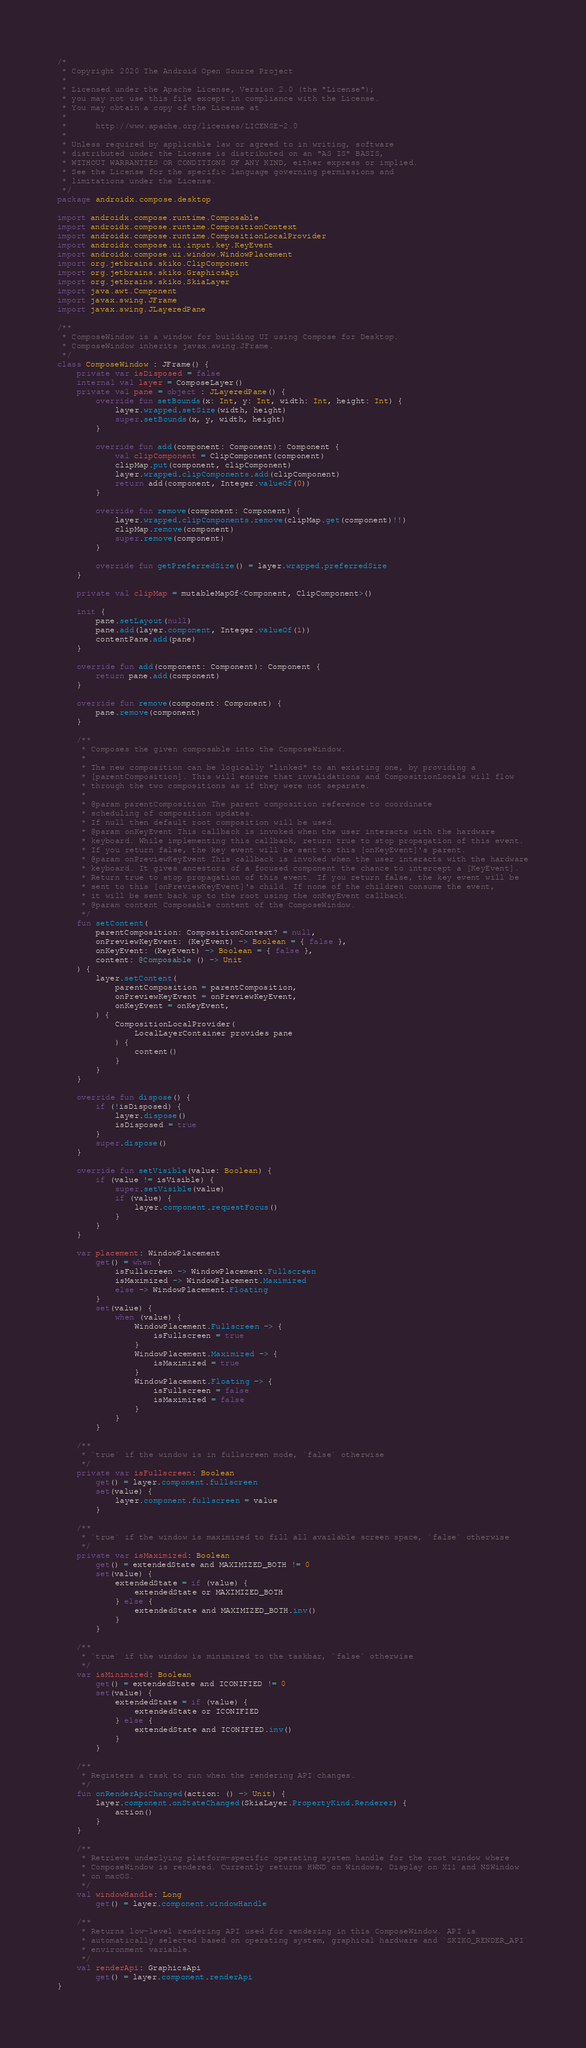<code> <loc_0><loc_0><loc_500><loc_500><_Kotlin_>/*
 * Copyright 2020 The Android Open Source Project
 *
 * Licensed under the Apache License, Version 2.0 (the "License");
 * you may not use this file except in compliance with the License.
 * You may obtain a copy of the License at
 *
 *      http://www.apache.org/licenses/LICENSE-2.0
 *
 * Unless required by applicable law or agreed to in writing, software
 * distributed under the License is distributed on an "AS IS" BASIS,
 * WITHOUT WARRANTIES OR CONDITIONS OF ANY KIND, either express or implied.
 * See the License for the specific language governing permissions and
 * limitations under the License.
 */
package androidx.compose.desktop

import androidx.compose.runtime.Composable
import androidx.compose.runtime.CompositionContext
import androidx.compose.runtime.CompositionLocalProvider
import androidx.compose.ui.input.key.KeyEvent
import androidx.compose.ui.window.WindowPlacement
import org.jetbrains.skiko.ClipComponent
import org.jetbrains.skiko.GraphicsApi
import org.jetbrains.skiko.SkiaLayer
import java.awt.Component
import javax.swing.JFrame
import javax.swing.JLayeredPane

/**
 * ComposeWindow is a window for building UI using Compose for Desktop.
 * ComposeWindow inherits javax.swing.JFrame.
 */
class ComposeWindow : JFrame() {
    private var isDisposed = false
    internal val layer = ComposeLayer()
    private val pane = object : JLayeredPane() {
        override fun setBounds(x: Int, y: Int, width: Int, height: Int) {
            layer.wrapped.setSize(width, height)
            super.setBounds(x, y, width, height)
        }

        override fun add(component: Component): Component {
            val clipComponent = ClipComponent(component)
            clipMap.put(component, clipComponent)
            layer.wrapped.clipComponents.add(clipComponent)
            return add(component, Integer.valueOf(0))
        }

        override fun remove(component: Component) {
            layer.wrapped.clipComponents.remove(clipMap.get(component)!!)
            clipMap.remove(component)
            super.remove(component)
        }

        override fun getPreferredSize() = layer.wrapped.preferredSize
    }

    private val clipMap = mutableMapOf<Component, ClipComponent>()

    init {
        pane.setLayout(null)
        pane.add(layer.component, Integer.valueOf(1))
        contentPane.add(pane)
    }

    override fun add(component: Component): Component {
        return pane.add(component)
    }

    override fun remove(component: Component) {
        pane.remove(component)
    }

    /**
     * Composes the given composable into the ComposeWindow.
     *
     * The new composition can be logically "linked" to an existing one, by providing a
     * [parentComposition]. This will ensure that invalidations and CompositionLocals will flow
     * through the two compositions as if they were not separate.
     *
     * @param parentComposition The parent composition reference to coordinate
     * scheduling of composition updates.
     * If null then default root composition will be used.
     * @param onKeyEvent This callback is invoked when the user interacts with the hardware
     * keyboard. While implementing this callback, return true to stop propagation of this event.
     * If you return false, the key event will be sent to this [onKeyEvent]'s parent.
     * @param onPreviewKeyEvent This callback is invoked when the user interacts with the hardware
     * keyboard. It gives ancestors of a focused component the chance to intercept a [KeyEvent].
     * Return true to stop propagation of this event. If you return false, the key event will be
     * sent to this [onPreviewKeyEvent]'s child. If none of the children consume the event,
     * it will be sent back up to the root using the onKeyEvent callback.
     * @param content Composable content of the ComposeWindow.
     */
    fun setContent(
        parentComposition: CompositionContext? = null,
        onPreviewKeyEvent: (KeyEvent) -> Boolean = { false },
        onKeyEvent: (KeyEvent) -> Boolean = { false },
        content: @Composable () -> Unit
    ) {
        layer.setContent(
            parentComposition = parentComposition,
            onPreviewKeyEvent = onPreviewKeyEvent,
            onKeyEvent = onKeyEvent,
        ) {
            CompositionLocalProvider(
                LocalLayerContainer provides pane
            ) {
                content()
            }
        }
    }

    override fun dispose() {
        if (!isDisposed) {
            layer.dispose()
            isDisposed = true
        }
        super.dispose()
    }

    override fun setVisible(value: Boolean) {
        if (value != isVisible) {
            super.setVisible(value)
            if (value) {
                layer.component.requestFocus()
            }
        }
    }

    var placement: WindowPlacement
        get() = when {
            isFullscreen -> WindowPlacement.Fullscreen
            isMaximized -> WindowPlacement.Maximized
            else -> WindowPlacement.Floating
        }
        set(value) {
            when (value) {
                WindowPlacement.Fullscreen -> {
                    isFullscreen = true
                }
                WindowPlacement.Maximized -> {
                    isMaximized = true
                }
                WindowPlacement.Floating -> {
                    isFullscreen = false
                    isMaximized = false
                }
            }
        }

    /**
     * `true` if the window is in fullscreen mode, `false` otherwise
     */
    private var isFullscreen: Boolean
        get() = layer.component.fullscreen
        set(value) {
            layer.component.fullscreen = value
        }

    /**
     * `true` if the window is maximized to fill all available screen space, `false` otherwise
     */
    private var isMaximized: Boolean
        get() = extendedState and MAXIMIZED_BOTH != 0
        set(value) {
            extendedState = if (value) {
                extendedState or MAXIMIZED_BOTH
            } else {
                extendedState and MAXIMIZED_BOTH.inv()
            }
        }

    /**
     * `true` if the window is minimized to the taskbar, `false` otherwise
     */
    var isMinimized: Boolean
        get() = extendedState and ICONIFIED != 0
        set(value) {
            extendedState = if (value) {
                extendedState or ICONIFIED
            } else {
                extendedState and ICONIFIED.inv()
            }
        }

    /**
     * Registers a task to run when the rendering API changes.
     */
    fun onRenderApiChanged(action: () -> Unit) {
        layer.component.onStateChanged(SkiaLayer.PropertyKind.Renderer) {
            action()
        }
    }

    /**
     * Retrieve underlying platform-specific operating system handle for the root window where
     * ComposeWindow is rendered. Currently returns HWND on Windows, Display on X11 and NSWindow
     * on macOS.
     */
    val windowHandle: Long
        get() = layer.component.windowHandle

    /**
     * Returns low-level rendering API used for rendering in this ComposeWindow. API is
     * automatically selected based on operating system, graphical hardware and `SKIKO_RENDER_API`
     * environment variable.
     */
    val renderApi: GraphicsApi
        get() = layer.component.renderApi
}
</code> 